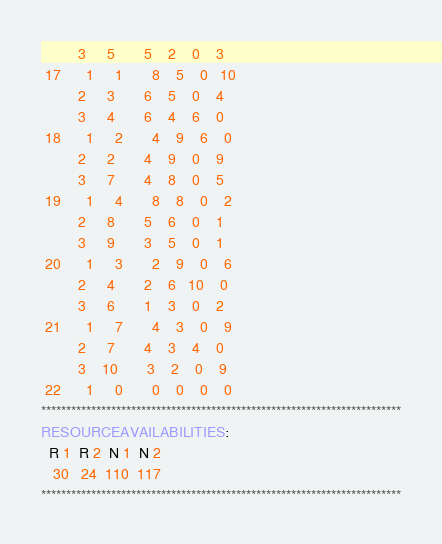Convert code to text. <code><loc_0><loc_0><loc_500><loc_500><_ObjectiveC_>         3     5       5    2    0    3
 17      1     1       8    5    0   10
         2     3       6    5    0    4
         3     4       6    4    6    0
 18      1     2       4    9    6    0
         2     2       4    9    0    9
         3     7       4    8    0    5
 19      1     4       8    8    0    2
         2     8       5    6    0    1
         3     9       3    5    0    1
 20      1     3       2    9    0    6
         2     4       2    6   10    0
         3     6       1    3    0    2
 21      1     7       4    3    0    9
         2     7       4    3    4    0
         3    10       3    2    0    9
 22      1     0       0    0    0    0
************************************************************************
RESOURCEAVAILABILITIES:
  R 1  R 2  N 1  N 2
   30   24  110  117
************************************************************************
</code> 